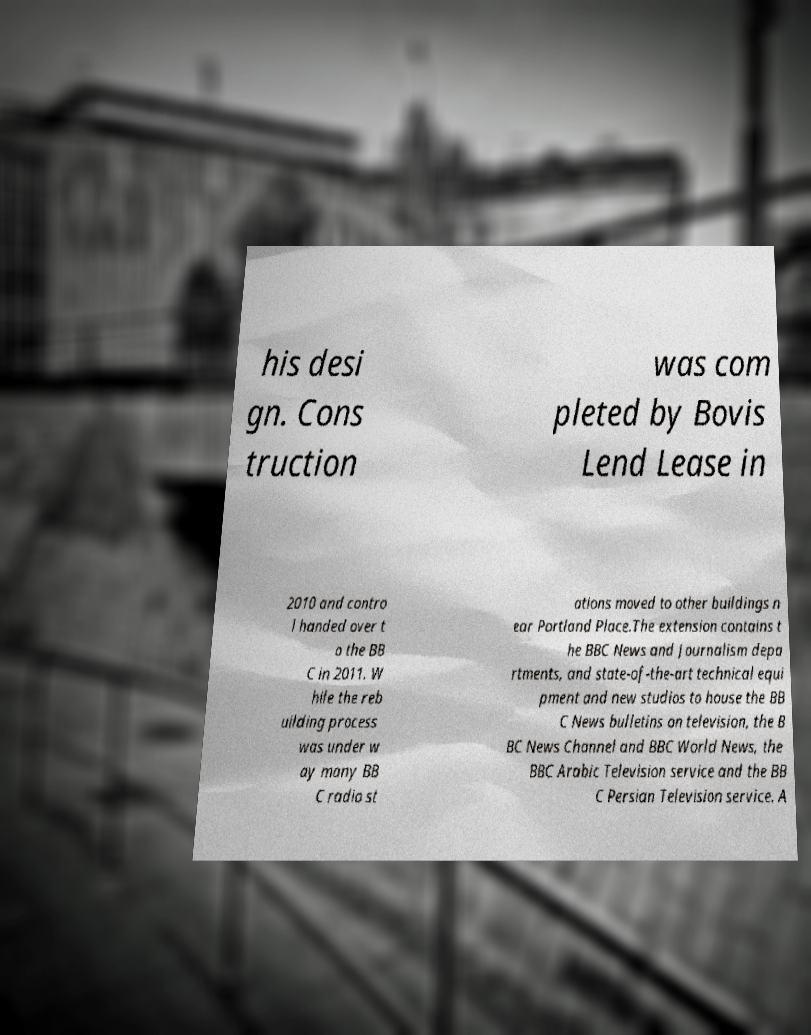For documentation purposes, I need the text within this image transcribed. Could you provide that? his desi gn. Cons truction was com pleted by Bovis Lend Lease in 2010 and contro l handed over t o the BB C in 2011. W hile the reb uilding process was under w ay many BB C radio st ations moved to other buildings n ear Portland Place.The extension contains t he BBC News and Journalism depa rtments, and state-of-the-art technical equi pment and new studios to house the BB C News bulletins on television, the B BC News Channel and BBC World News, the BBC Arabic Television service and the BB C Persian Television service. A 